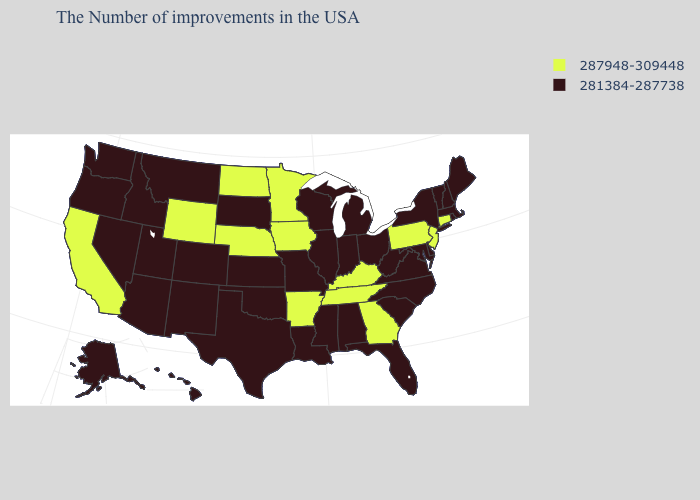Does Georgia have the same value as Nebraska?
Concise answer only. Yes. What is the highest value in the USA?
Give a very brief answer. 287948-309448. What is the lowest value in states that border New Hampshire?
Answer briefly. 281384-287738. What is the lowest value in the USA?
Answer briefly. 281384-287738. What is the lowest value in the USA?
Write a very short answer. 281384-287738. What is the value of Wisconsin?
Give a very brief answer. 281384-287738. What is the value of Oklahoma?
Answer briefly. 281384-287738. What is the value of Michigan?
Short answer required. 281384-287738. Does Wyoming have the same value as Kentucky?
Short answer required. Yes. Which states have the lowest value in the USA?
Quick response, please. Maine, Massachusetts, Rhode Island, New Hampshire, Vermont, New York, Delaware, Maryland, Virginia, North Carolina, South Carolina, West Virginia, Ohio, Florida, Michigan, Indiana, Alabama, Wisconsin, Illinois, Mississippi, Louisiana, Missouri, Kansas, Oklahoma, Texas, South Dakota, Colorado, New Mexico, Utah, Montana, Arizona, Idaho, Nevada, Washington, Oregon, Alaska, Hawaii. Name the states that have a value in the range 281384-287738?
Keep it brief. Maine, Massachusetts, Rhode Island, New Hampshire, Vermont, New York, Delaware, Maryland, Virginia, North Carolina, South Carolina, West Virginia, Ohio, Florida, Michigan, Indiana, Alabama, Wisconsin, Illinois, Mississippi, Louisiana, Missouri, Kansas, Oklahoma, Texas, South Dakota, Colorado, New Mexico, Utah, Montana, Arizona, Idaho, Nevada, Washington, Oregon, Alaska, Hawaii. What is the value of Arizona?
Write a very short answer. 281384-287738. Which states have the lowest value in the USA?
Concise answer only. Maine, Massachusetts, Rhode Island, New Hampshire, Vermont, New York, Delaware, Maryland, Virginia, North Carolina, South Carolina, West Virginia, Ohio, Florida, Michigan, Indiana, Alabama, Wisconsin, Illinois, Mississippi, Louisiana, Missouri, Kansas, Oklahoma, Texas, South Dakota, Colorado, New Mexico, Utah, Montana, Arizona, Idaho, Nevada, Washington, Oregon, Alaska, Hawaii. Which states have the lowest value in the South?
Give a very brief answer. Delaware, Maryland, Virginia, North Carolina, South Carolina, West Virginia, Florida, Alabama, Mississippi, Louisiana, Oklahoma, Texas. What is the value of Georgia?
Write a very short answer. 287948-309448. 